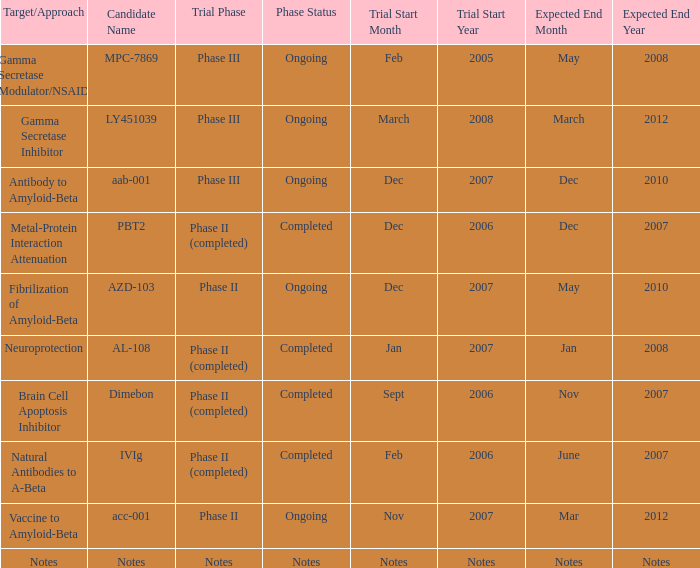When the target/approach is notes, what is the anticipated completion date? Notes. 